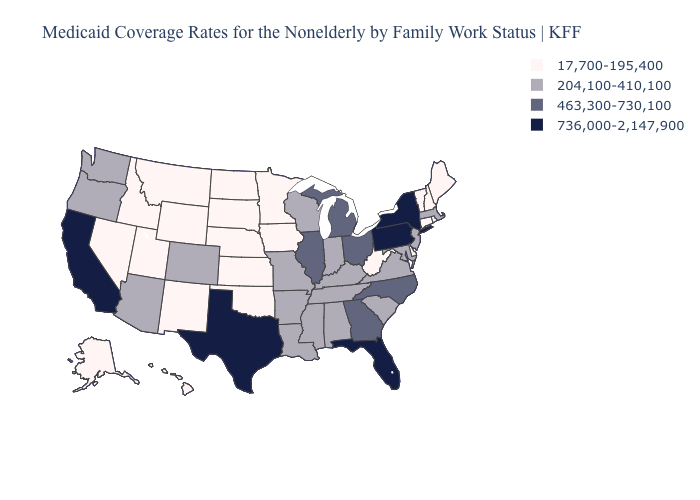What is the highest value in the USA?
Give a very brief answer. 736,000-2,147,900. What is the value of South Dakota?
Short answer required. 17,700-195,400. Which states have the highest value in the USA?
Keep it brief. California, Florida, New York, Pennsylvania, Texas. Name the states that have a value in the range 736,000-2,147,900?
Concise answer only. California, Florida, New York, Pennsylvania, Texas. Name the states that have a value in the range 17,700-195,400?
Give a very brief answer. Alaska, Connecticut, Delaware, Hawaii, Idaho, Iowa, Kansas, Maine, Minnesota, Montana, Nebraska, Nevada, New Hampshire, New Mexico, North Dakota, Oklahoma, Rhode Island, South Dakota, Utah, Vermont, West Virginia, Wyoming. What is the lowest value in the USA?
Short answer required. 17,700-195,400. Name the states that have a value in the range 736,000-2,147,900?
Keep it brief. California, Florida, New York, Pennsylvania, Texas. What is the value of Alabama?
Short answer required. 204,100-410,100. Does Mississippi have a higher value than Vermont?
Quick response, please. Yes. How many symbols are there in the legend?
Concise answer only. 4. Does Arkansas have the highest value in the USA?
Concise answer only. No. Does Hawaii have the same value as Michigan?
Give a very brief answer. No. Name the states that have a value in the range 736,000-2,147,900?
Give a very brief answer. California, Florida, New York, Pennsylvania, Texas. What is the highest value in the USA?
Give a very brief answer. 736,000-2,147,900. Does the first symbol in the legend represent the smallest category?
Keep it brief. Yes. 